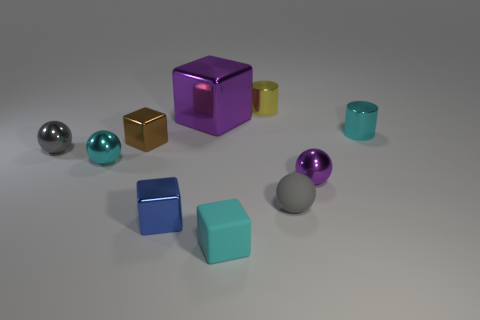What can you tell me about the spherical objects? There are three spherical objects visible in the scene. On the left, there is a shiny, reflective silver sphere, and next to it a smaller turquoise sphere with a similar metallic sheen. On the right, there is a purple sphere that appears to have a glossy finish, reflecting light and the environment around it. 